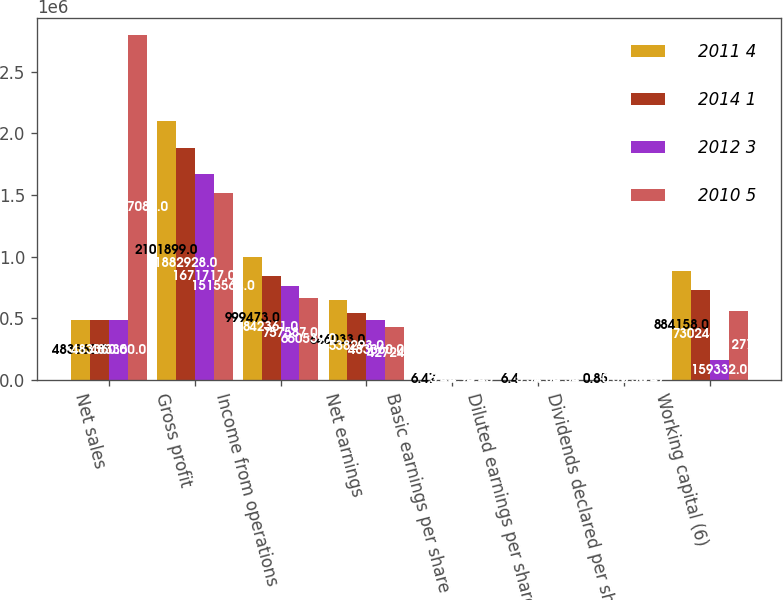Convert chart to OTSL. <chart><loc_0><loc_0><loc_500><loc_500><stacked_bar_chart><ecel><fcel>Net sales<fcel>Gross profit<fcel>Income from operations<fcel>Net earnings<fcel>Basic earnings per share<fcel>Diluted earnings per share<fcel>Dividends declared per share<fcel>Working capital (6)<nl><fcel>2011 4<fcel>483360<fcel>2.1019e+06<fcel>999473<fcel>646033<fcel>6.47<fcel>6.4<fcel>0.85<fcel>884158<nl><fcel>2014 1<fcel>483360<fcel>1.88293e+06<fcel>842361<fcel>538293<fcel>5.43<fcel>5.37<fcel>0.69<fcel>730246<nl><fcel>2012 3<fcel>483360<fcel>1.67172e+06<fcel>757587<fcel>483360<fcel>4.95<fcel>4.86<fcel>0.58<fcel>159332<nl><fcel>2010 5<fcel>2.79709e+06<fcel>1.51556e+06<fcel>660539<fcel>427247<fcel>4.45<fcel>4.34<fcel>0.47<fcel>561277<nl></chart> 